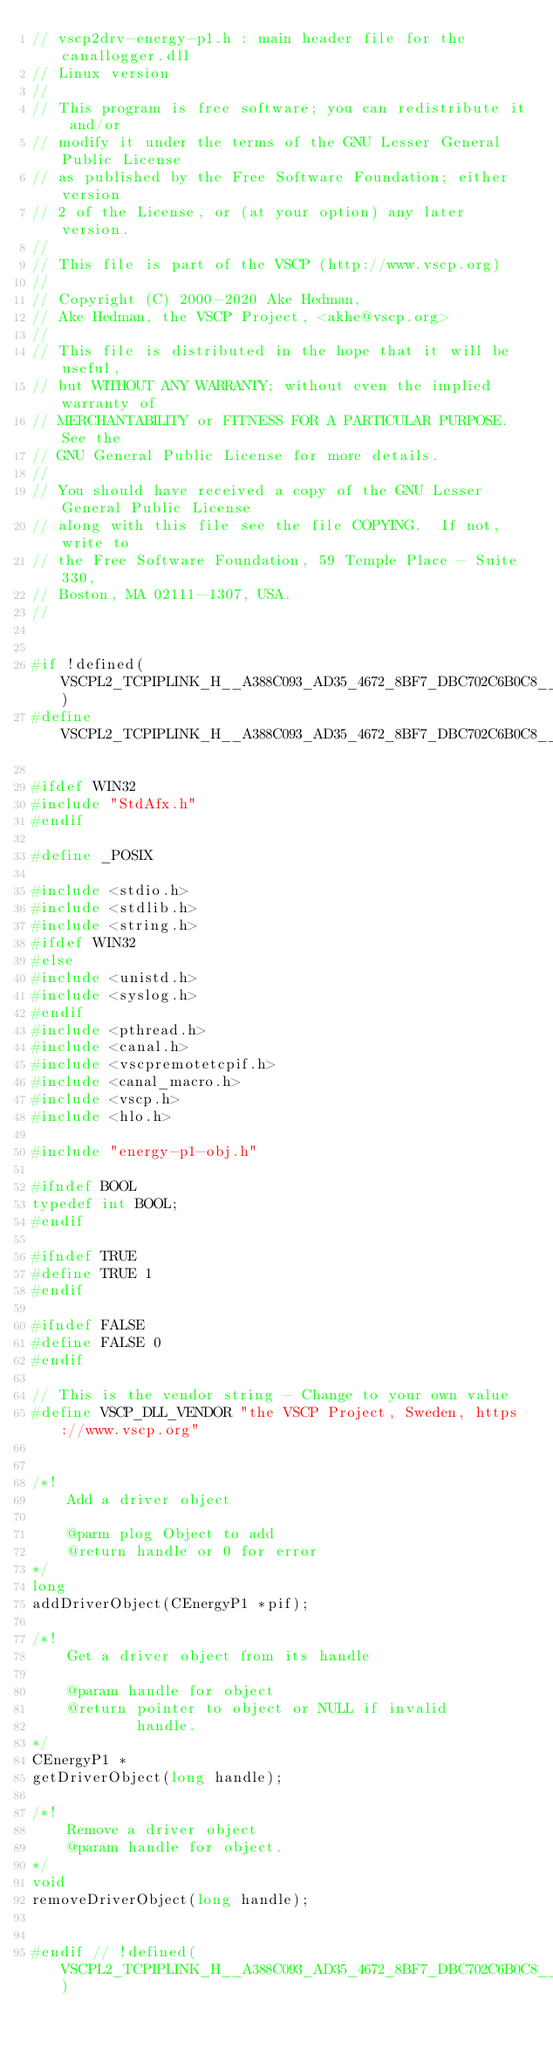Convert code to text. <code><loc_0><loc_0><loc_500><loc_500><_C_>// vscp2drv-energy-p1.h : main header file for the canallogger.dll
// Linux version
//
// This program is free software; you can redistribute it and/or
// modify it under the terms of the GNU Lesser General Public License
// as published by the Free Software Foundation; either version
// 2 of the License, or (at your option) any later version.
// 
// This file is part of the VSCP (http://www.vscp.org) 
//
// Copyright (C) 2000-2020 Ake Hedman, 
// Ake Hedman, the VSCP Project, <akhe@vscp.org>
// 
// This file is distributed in the hope that it will be useful,
// but WITHOUT ANY WARRANTY; without even the implied warranty of
// MERCHANTABILITY or FITNESS FOR A PARTICULAR PURPOSE.  See the
// GNU General Public License for more details.
// 
// You should have received a copy of the GNU Lesser  General Public License
// along with this file see the file COPYING.  If not, write to
// the Free Software Foundation, 59 Temple Place - Suite 330,
// Boston, MA 02111-1307, USA.
//


#if !defined(VSCPL2_TCPIPLINK_H__A388C093_AD35_4672_8BF7_DBC702C6B0C8__INCLUDED_)
#define VSCPL2_TCPIPLINK_H__A388C093_AD35_4672_8BF7_DBC702C6B0C8__INCLUDED_

#ifdef WIN32
#include "StdAfx.h"
#endif

#define _POSIX

#include <stdio.h>
#include <stdlib.h>
#include <string.h>
#ifdef WIN32
#else
#include <unistd.h>
#include <syslog.h>
#endif
#include <pthread.h>
#include <canal.h>
#include <vscpremotetcpif.h>
#include <canal_macro.h>
#include <vscp.h>
#include <hlo.h>

#include "energy-p1-obj.h"

#ifndef BOOL
typedef int BOOL;
#endif

#ifndef TRUE
#define TRUE 1
#endif

#ifndef FALSE
#define FALSE 0
#endif

// This is the vendor string - Change to your own value
#define VSCP_DLL_VENDOR "the VSCP Project, Sweden, https://www.vscp.org"


/*!
    Add a driver object

    @parm plog Object to add
    @return handle or 0 for error
*/
long
addDriverObject(CEnergyP1 *pif);

/*!
    Get a driver object from its handle

    @param handle for object
    @return pointer to object or NULL if invalid
            handle.
*/
CEnergyP1 *
getDriverObject(long handle);

/*!
    Remove a driver object
    @param handle for object.
*/
void
removeDriverObject(long handle);


#endif // !defined(VSCPL2_TCPIPLINK_H__A388C093_AD35_4672_8BF7_DBC702C6B0C8__INCLUDED_)
</code> 